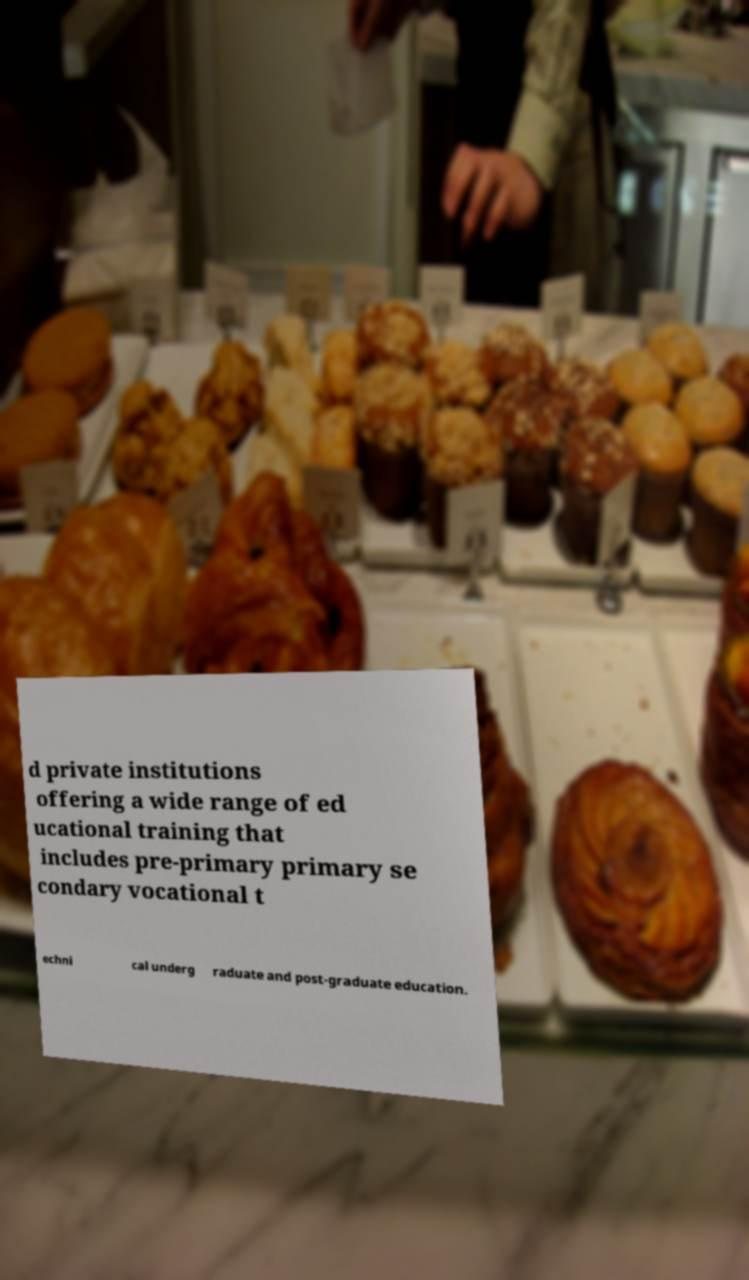For documentation purposes, I need the text within this image transcribed. Could you provide that? d private institutions offering a wide range of ed ucational training that includes pre-primary primary se condary vocational t echni cal underg raduate and post-graduate education. 